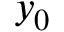Convert formula to latex. <formula><loc_0><loc_0><loc_500><loc_500>y _ { 0 }</formula> 